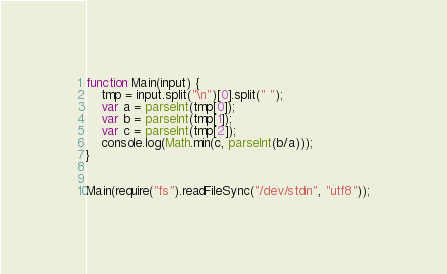<code> <loc_0><loc_0><loc_500><loc_500><_JavaScript_>function Main(input) {
	tmp = input.split("\n")[0].split(" ");
	var a = parseInt(tmp[0]);
	var b = parseInt(tmp[1]);
	var c = parseInt(tmp[2]);
	console.log(Math.min(c, parseInt(b/a)));
}


Main(require("fs").readFileSync("/dev/stdin", "utf8"));</code> 